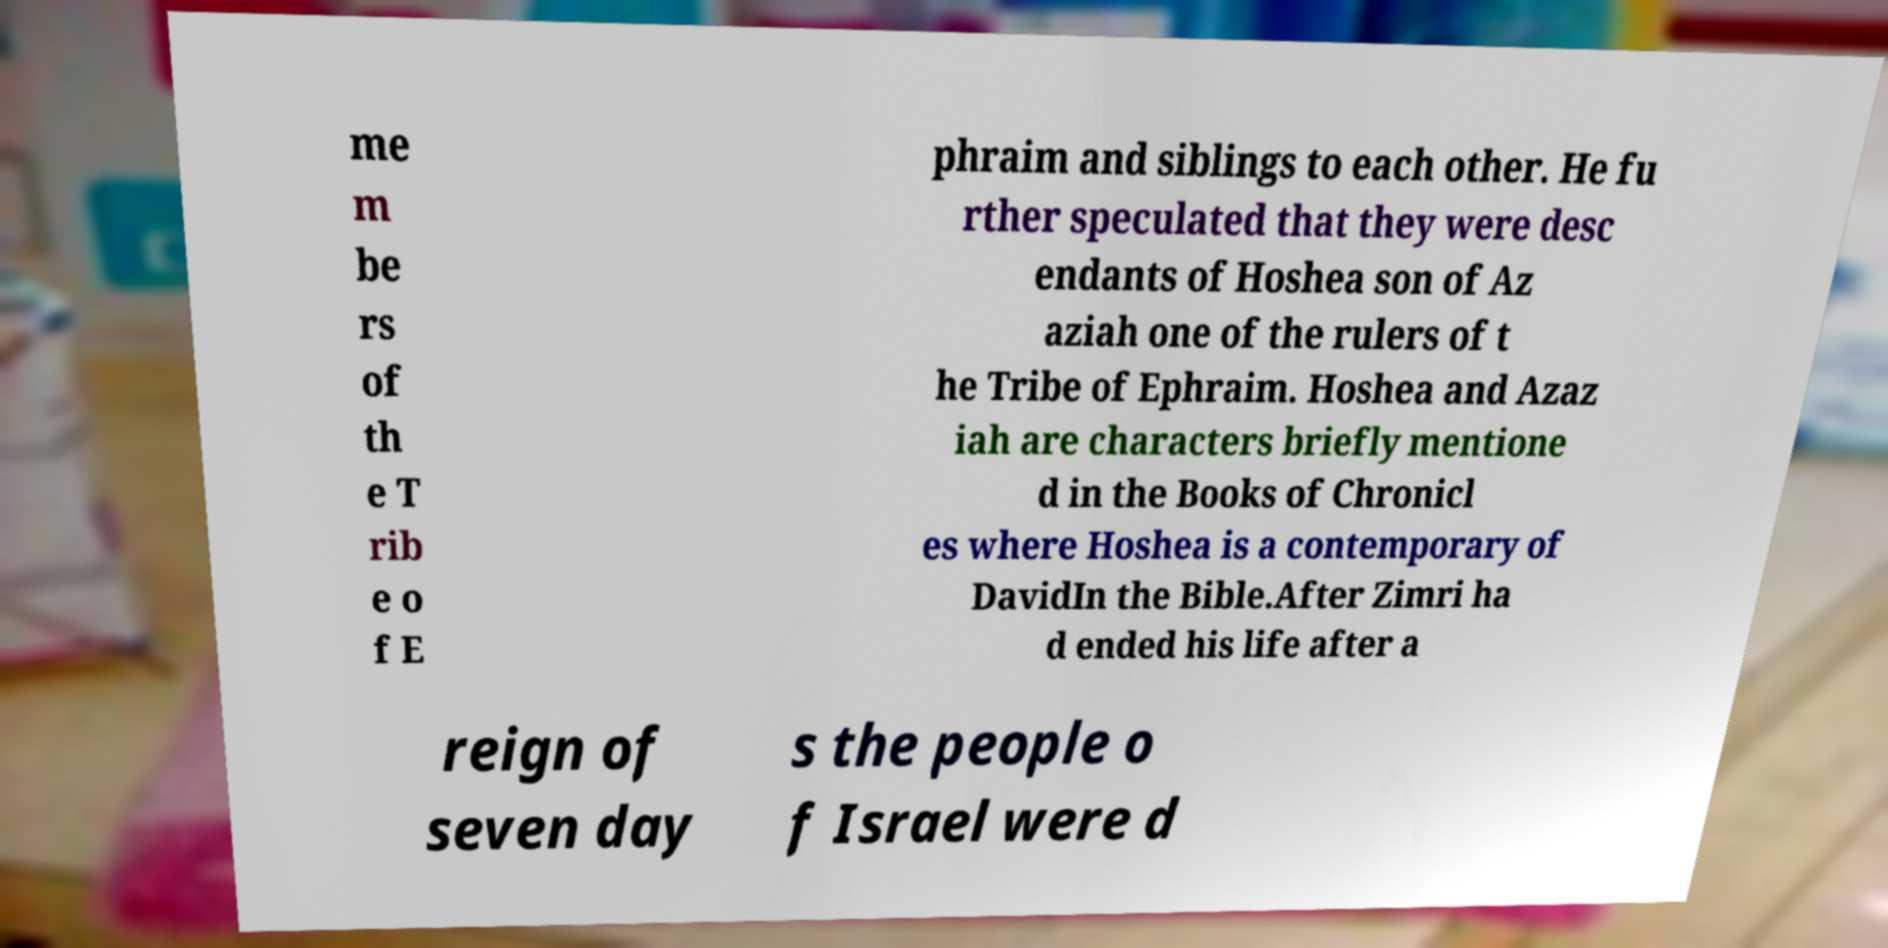Can you read and provide the text displayed in the image?This photo seems to have some interesting text. Can you extract and type it out for me? me m be rs of th e T rib e o f E phraim and siblings to each other. He fu rther speculated that they were desc endants of Hoshea son of Az aziah one of the rulers of t he Tribe of Ephraim. Hoshea and Azaz iah are characters briefly mentione d in the Books of Chronicl es where Hoshea is a contemporary of DavidIn the Bible.After Zimri ha d ended his life after a reign of seven day s the people o f Israel were d 